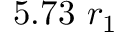<formula> <loc_0><loc_0><loc_500><loc_500>5 . 7 3 r _ { 1 }</formula> 